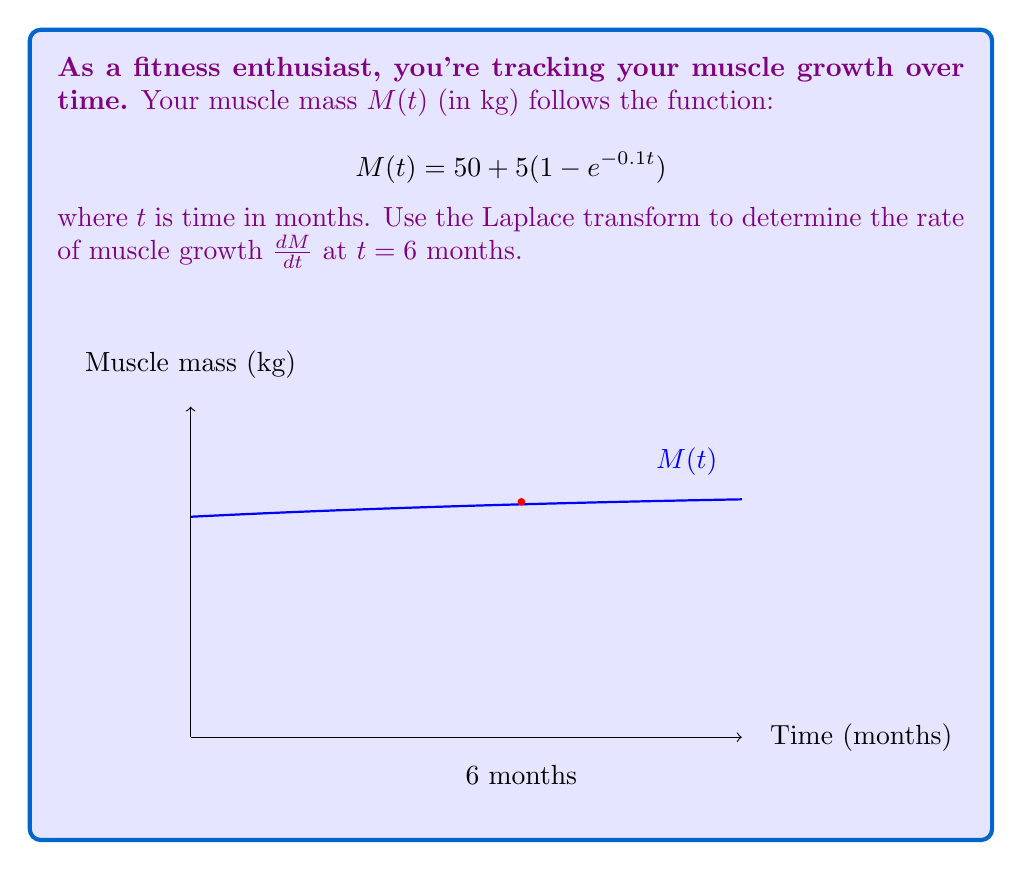What is the answer to this math problem? Let's approach this step-by-step using the Laplace transform:

1) First, we need to find the Laplace transform of $M(t)$:
   $$\mathcal{L}\{M(t)\} = \mathcal{L}\{50 + 5(1 - e^{-0.1t})\}$$

2) Using linearity and shift properties:
   $$\mathcal{L}\{M(t)\} = \frac{50}{s} + \frac{5}{s} - 5\mathcal{L}\{e^{-0.1t}\}$$

3) We know that $\mathcal{L}\{e^{-at}\} = \frac{1}{s+a}$, so:
   $$\mathcal{L}\{M(t)\} = \frac{50}{s} + \frac{5}{s} - \frac{5}{s+0.1}$$

4) To find the rate of growth, we need $\frac{dM}{dt}$. In Laplace domain, this is equivalent to multiplying by $s$ and subtracting the initial value:
   $$\mathcal{L}\{\frac{dM}{dt}\} = s\mathcal{L}\{M(t)\} - M(0)$$

5) Substituting:
   $$\mathcal{L}\{\frac{dM}{dt}\} = s(\frac{50}{s} + \frac{5}{s} - \frac{5}{s+0.1}) - 50$$

6) Simplifying:
   $$\mathcal{L}\{\frac{dM}{dt}\} = 50 + 5 - \frac{5s}{s+0.1} - 50 = 5 - \frac{5s}{s+0.1}$$

7) Using partial fraction decomposition:
   $$\mathcal{L}\{\frac{dM}{dt}\} = 5 - \frac{5s}{s+0.1} = 5 - 5 + \frac{0.5}{s+0.1} = \frac{0.5}{s+0.1}$$

8) Taking the inverse Laplace transform:
   $$\frac{dM}{dt} = 0.5e^{-0.1t}$$

9) Evaluating at $t = 6$ months:
   $$\frac{dM}{dt}|_{t=6} = 0.5e^{-0.1(6)} = 0.5e^{-0.6} \approx 0.2746$$

Therefore, the rate of muscle growth at 6 months is approximately 0.2746 kg/month.
Answer: $0.2746$ kg/month 